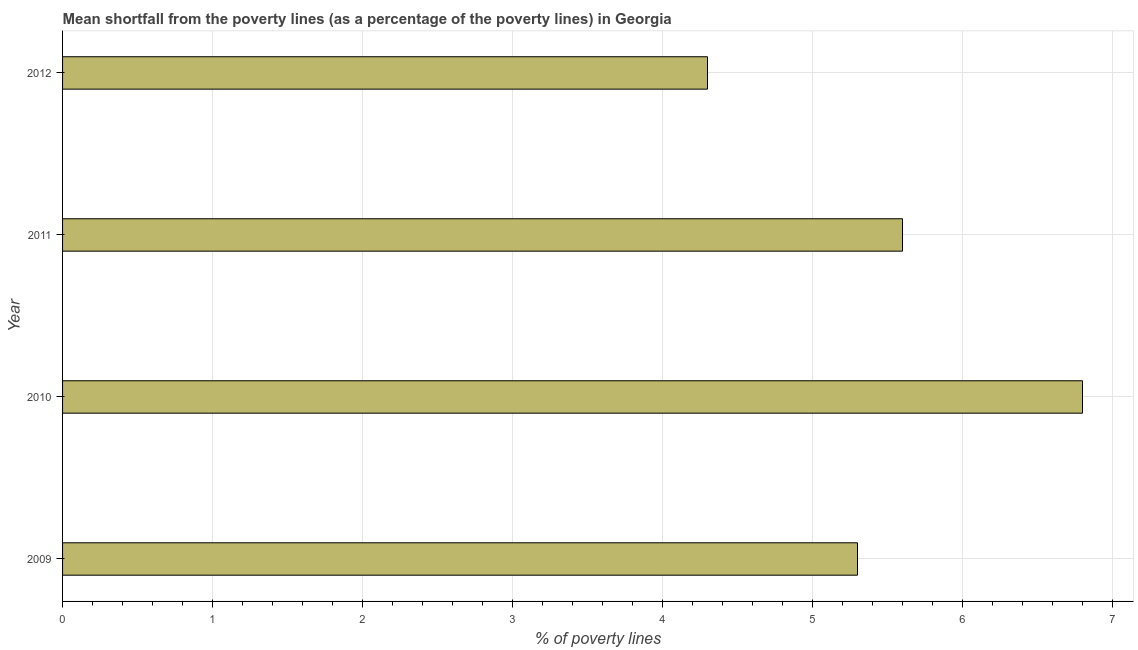What is the title of the graph?
Keep it short and to the point. Mean shortfall from the poverty lines (as a percentage of the poverty lines) in Georgia. What is the label or title of the X-axis?
Your response must be concise. % of poverty lines. What is the label or title of the Y-axis?
Your answer should be compact. Year. What is the poverty gap at national poverty lines in 2010?
Your answer should be very brief. 6.8. Across all years, what is the maximum poverty gap at national poverty lines?
Offer a terse response. 6.8. In which year was the poverty gap at national poverty lines maximum?
Give a very brief answer. 2010. In which year was the poverty gap at national poverty lines minimum?
Give a very brief answer. 2012. What is the sum of the poverty gap at national poverty lines?
Your answer should be very brief. 22. What is the average poverty gap at national poverty lines per year?
Keep it short and to the point. 5.5. What is the median poverty gap at national poverty lines?
Give a very brief answer. 5.45. In how many years, is the poverty gap at national poverty lines greater than 4 %?
Provide a succinct answer. 4. Do a majority of the years between 2011 and 2012 (inclusive) have poverty gap at national poverty lines greater than 2.4 %?
Make the answer very short. Yes. What is the ratio of the poverty gap at national poverty lines in 2010 to that in 2012?
Your answer should be compact. 1.58. What is the difference between the highest and the lowest poverty gap at national poverty lines?
Make the answer very short. 2.5. In how many years, is the poverty gap at national poverty lines greater than the average poverty gap at national poverty lines taken over all years?
Provide a short and direct response. 2. Are all the bars in the graph horizontal?
Your answer should be compact. Yes. What is the difference between two consecutive major ticks on the X-axis?
Offer a very short reply. 1. Are the values on the major ticks of X-axis written in scientific E-notation?
Your response must be concise. No. What is the % of poverty lines of 2010?
Give a very brief answer. 6.8. What is the % of poverty lines in 2011?
Ensure brevity in your answer.  5.6. What is the % of poverty lines in 2012?
Make the answer very short. 4.3. What is the difference between the % of poverty lines in 2009 and 2010?
Provide a succinct answer. -1.5. What is the difference between the % of poverty lines in 2009 and 2011?
Provide a succinct answer. -0.3. What is the difference between the % of poverty lines in 2009 and 2012?
Your answer should be compact. 1. What is the difference between the % of poverty lines in 2010 and 2011?
Provide a short and direct response. 1.2. What is the ratio of the % of poverty lines in 2009 to that in 2010?
Provide a short and direct response. 0.78. What is the ratio of the % of poverty lines in 2009 to that in 2011?
Ensure brevity in your answer.  0.95. What is the ratio of the % of poverty lines in 2009 to that in 2012?
Offer a terse response. 1.23. What is the ratio of the % of poverty lines in 2010 to that in 2011?
Offer a terse response. 1.21. What is the ratio of the % of poverty lines in 2010 to that in 2012?
Give a very brief answer. 1.58. What is the ratio of the % of poverty lines in 2011 to that in 2012?
Your response must be concise. 1.3. 